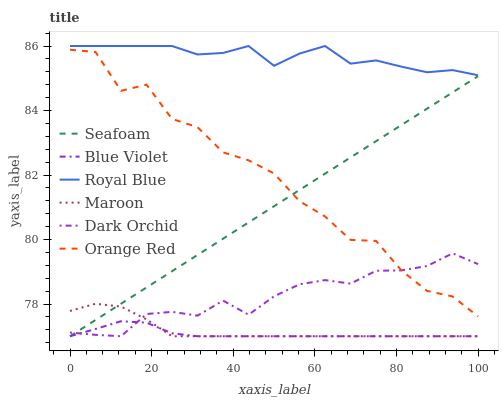Does Blue Violet have the minimum area under the curve?
Answer yes or no. Yes. Does Royal Blue have the maximum area under the curve?
Answer yes or no. Yes. Does Maroon have the minimum area under the curve?
Answer yes or no. No. Does Maroon have the maximum area under the curve?
Answer yes or no. No. Is Seafoam the smoothest?
Answer yes or no. Yes. Is Orange Red the roughest?
Answer yes or no. Yes. Is Maroon the smoothest?
Answer yes or no. No. Is Maroon the roughest?
Answer yes or no. No. Does Royal Blue have the lowest value?
Answer yes or no. No. Does Royal Blue have the highest value?
Answer yes or no. Yes. Does Maroon have the highest value?
Answer yes or no. No. Is Maroon less than Orange Red?
Answer yes or no. Yes. Is Royal Blue greater than Dark Orchid?
Answer yes or no. Yes. Does Seafoam intersect Blue Violet?
Answer yes or no. Yes. Is Seafoam less than Blue Violet?
Answer yes or no. No. Is Seafoam greater than Blue Violet?
Answer yes or no. No. Does Maroon intersect Orange Red?
Answer yes or no. No. 